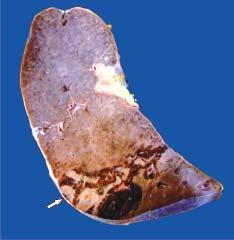s congo red congested?
Answer the question using a single word or phrase. No 